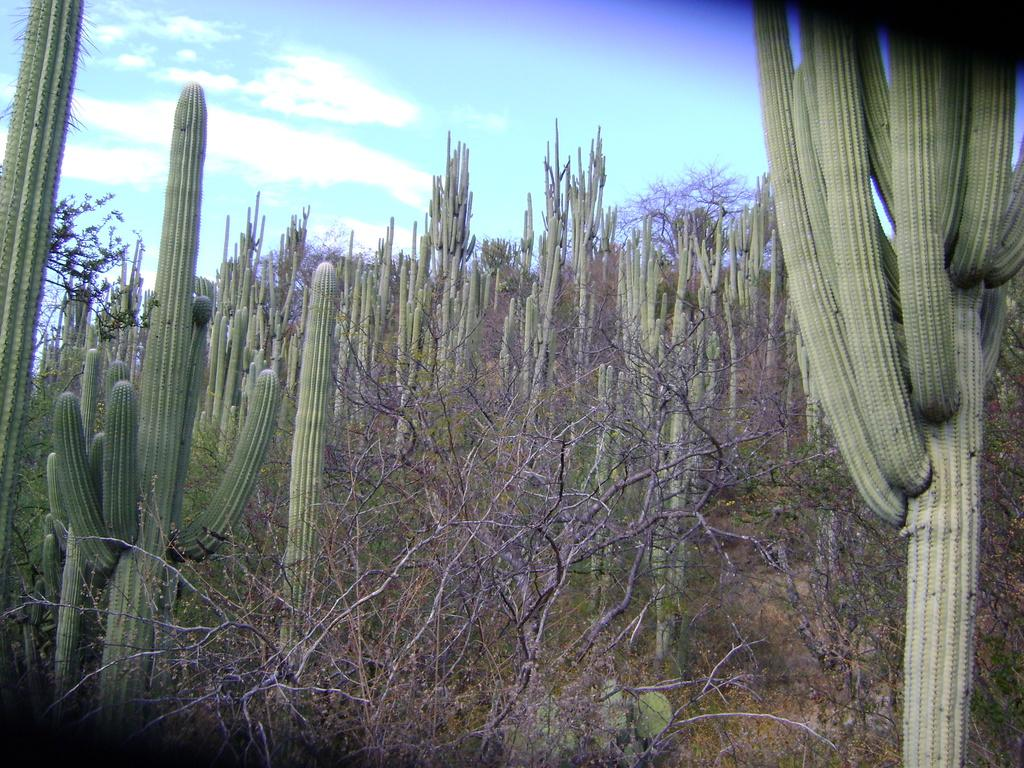What type of vegetation can be seen in the image? There are dry trees and cacti in the image. What color are the cacti? The cacti are green. What part of the natural environment is visible in the image? The sky is visible in the image. What type of ornament is hanging from the cacti in the image? There is no ornament hanging from the cacti in the image; the cacti are simply green plants. Can you smell the roses in the image? There are no roses present in the image, so it is not possible to smell them. 